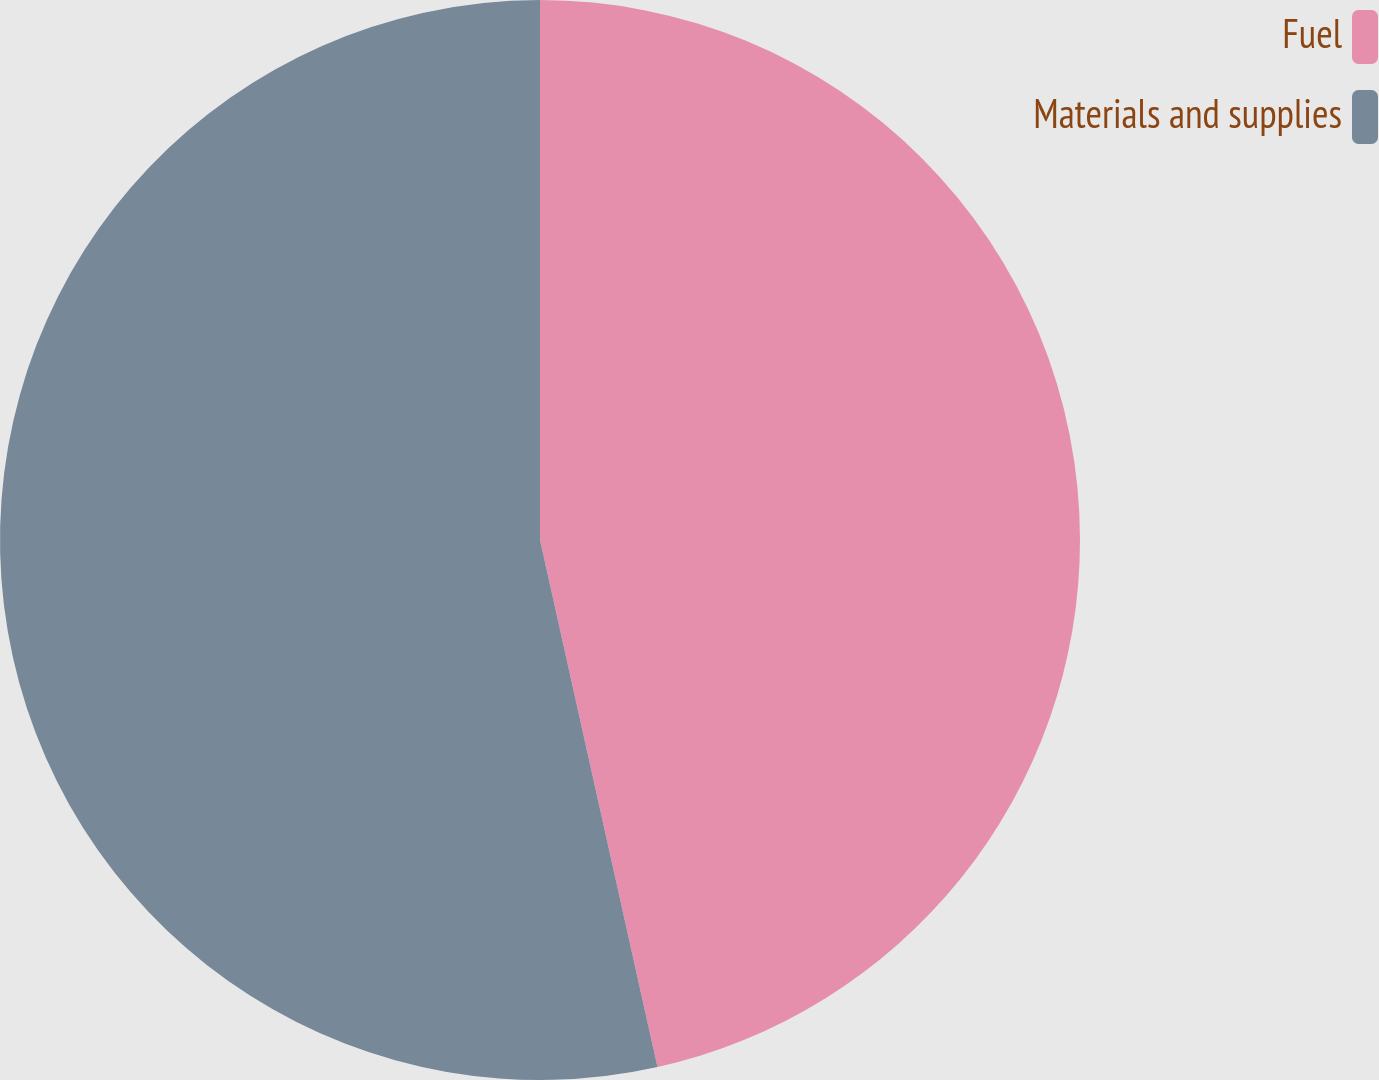<chart> <loc_0><loc_0><loc_500><loc_500><pie_chart><fcel>Fuel<fcel>Materials and supplies<nl><fcel>46.51%<fcel>53.49%<nl></chart> 